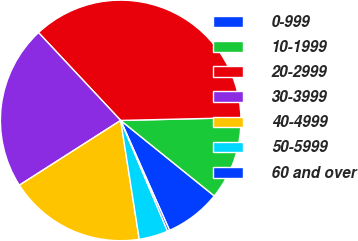Convert chart to OTSL. <chart><loc_0><loc_0><loc_500><loc_500><pie_chart><fcel>0-999<fcel>10-1999<fcel>20-2999<fcel>30-3999<fcel>40-4999<fcel>50-5999<fcel>60 and over<nl><fcel>7.54%<fcel>11.17%<fcel>36.6%<fcel>22.08%<fcel>18.41%<fcel>3.91%<fcel>0.28%<nl></chart> 